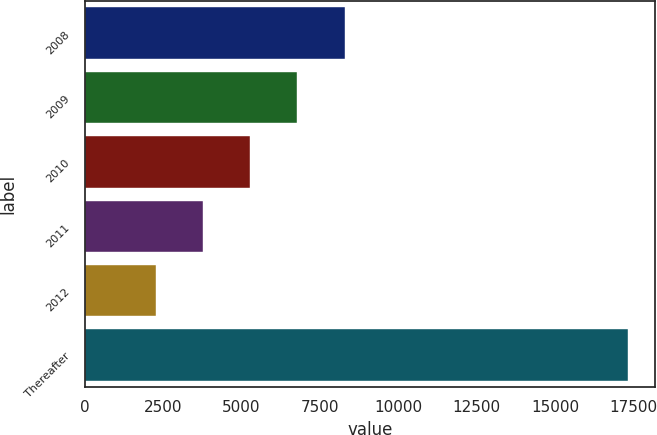Convert chart to OTSL. <chart><loc_0><loc_0><loc_500><loc_500><bar_chart><fcel>2008<fcel>2009<fcel>2010<fcel>2011<fcel>2012<fcel>Thereafter<nl><fcel>8290.8<fcel>6785.1<fcel>5279.4<fcel>3773.7<fcel>2268<fcel>17325<nl></chart> 